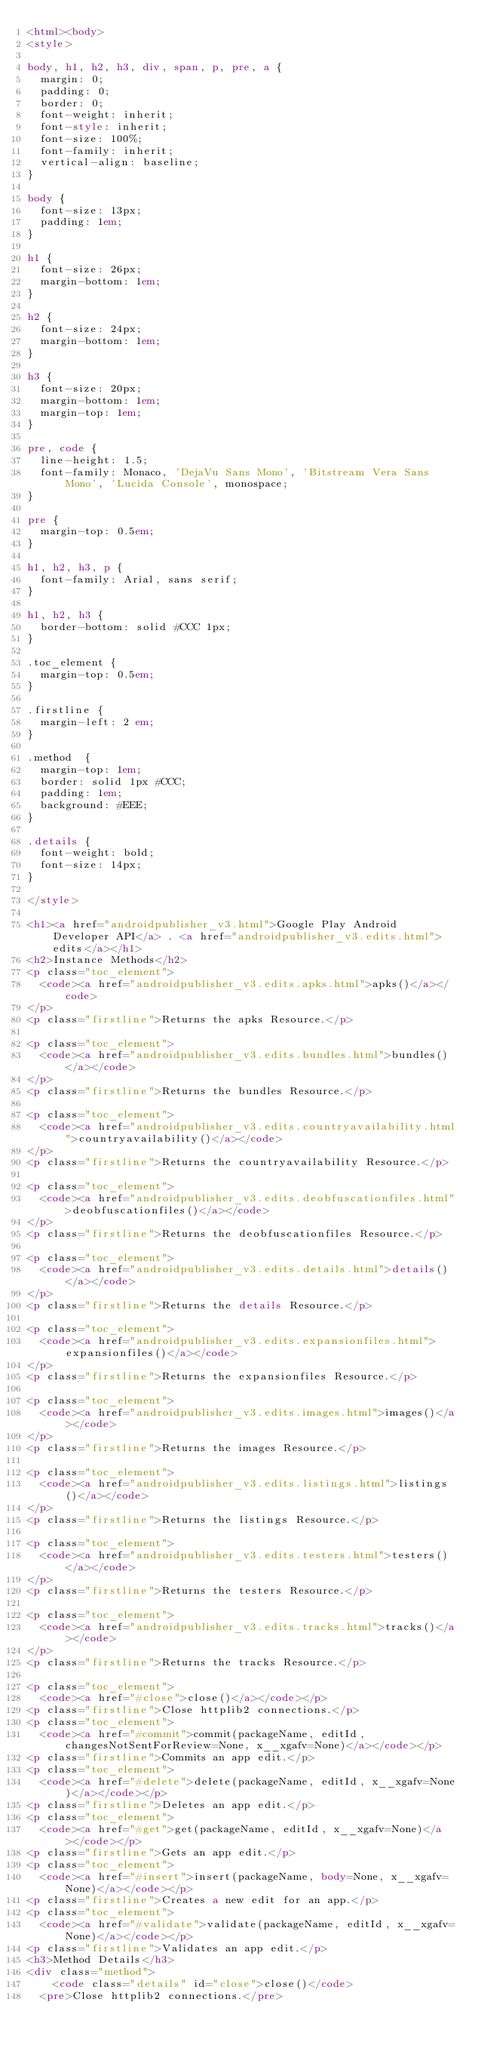Convert code to text. <code><loc_0><loc_0><loc_500><loc_500><_HTML_><html><body>
<style>

body, h1, h2, h3, div, span, p, pre, a {
  margin: 0;
  padding: 0;
  border: 0;
  font-weight: inherit;
  font-style: inherit;
  font-size: 100%;
  font-family: inherit;
  vertical-align: baseline;
}

body {
  font-size: 13px;
  padding: 1em;
}

h1 {
  font-size: 26px;
  margin-bottom: 1em;
}

h2 {
  font-size: 24px;
  margin-bottom: 1em;
}

h3 {
  font-size: 20px;
  margin-bottom: 1em;
  margin-top: 1em;
}

pre, code {
  line-height: 1.5;
  font-family: Monaco, 'DejaVu Sans Mono', 'Bitstream Vera Sans Mono', 'Lucida Console', monospace;
}

pre {
  margin-top: 0.5em;
}

h1, h2, h3, p {
  font-family: Arial, sans serif;
}

h1, h2, h3 {
  border-bottom: solid #CCC 1px;
}

.toc_element {
  margin-top: 0.5em;
}

.firstline {
  margin-left: 2 em;
}

.method  {
  margin-top: 1em;
  border: solid 1px #CCC;
  padding: 1em;
  background: #EEE;
}

.details {
  font-weight: bold;
  font-size: 14px;
}

</style>

<h1><a href="androidpublisher_v3.html">Google Play Android Developer API</a> . <a href="androidpublisher_v3.edits.html">edits</a></h1>
<h2>Instance Methods</h2>
<p class="toc_element">
  <code><a href="androidpublisher_v3.edits.apks.html">apks()</a></code>
</p>
<p class="firstline">Returns the apks Resource.</p>

<p class="toc_element">
  <code><a href="androidpublisher_v3.edits.bundles.html">bundles()</a></code>
</p>
<p class="firstline">Returns the bundles Resource.</p>

<p class="toc_element">
  <code><a href="androidpublisher_v3.edits.countryavailability.html">countryavailability()</a></code>
</p>
<p class="firstline">Returns the countryavailability Resource.</p>

<p class="toc_element">
  <code><a href="androidpublisher_v3.edits.deobfuscationfiles.html">deobfuscationfiles()</a></code>
</p>
<p class="firstline">Returns the deobfuscationfiles Resource.</p>

<p class="toc_element">
  <code><a href="androidpublisher_v3.edits.details.html">details()</a></code>
</p>
<p class="firstline">Returns the details Resource.</p>

<p class="toc_element">
  <code><a href="androidpublisher_v3.edits.expansionfiles.html">expansionfiles()</a></code>
</p>
<p class="firstline">Returns the expansionfiles Resource.</p>

<p class="toc_element">
  <code><a href="androidpublisher_v3.edits.images.html">images()</a></code>
</p>
<p class="firstline">Returns the images Resource.</p>

<p class="toc_element">
  <code><a href="androidpublisher_v3.edits.listings.html">listings()</a></code>
</p>
<p class="firstline">Returns the listings Resource.</p>

<p class="toc_element">
  <code><a href="androidpublisher_v3.edits.testers.html">testers()</a></code>
</p>
<p class="firstline">Returns the testers Resource.</p>

<p class="toc_element">
  <code><a href="androidpublisher_v3.edits.tracks.html">tracks()</a></code>
</p>
<p class="firstline">Returns the tracks Resource.</p>

<p class="toc_element">
  <code><a href="#close">close()</a></code></p>
<p class="firstline">Close httplib2 connections.</p>
<p class="toc_element">
  <code><a href="#commit">commit(packageName, editId, changesNotSentForReview=None, x__xgafv=None)</a></code></p>
<p class="firstline">Commits an app edit.</p>
<p class="toc_element">
  <code><a href="#delete">delete(packageName, editId, x__xgafv=None)</a></code></p>
<p class="firstline">Deletes an app edit.</p>
<p class="toc_element">
  <code><a href="#get">get(packageName, editId, x__xgafv=None)</a></code></p>
<p class="firstline">Gets an app edit.</p>
<p class="toc_element">
  <code><a href="#insert">insert(packageName, body=None, x__xgafv=None)</a></code></p>
<p class="firstline">Creates a new edit for an app.</p>
<p class="toc_element">
  <code><a href="#validate">validate(packageName, editId, x__xgafv=None)</a></code></p>
<p class="firstline">Validates an app edit.</p>
<h3>Method Details</h3>
<div class="method">
    <code class="details" id="close">close()</code>
  <pre>Close httplib2 connections.</pre></code> 